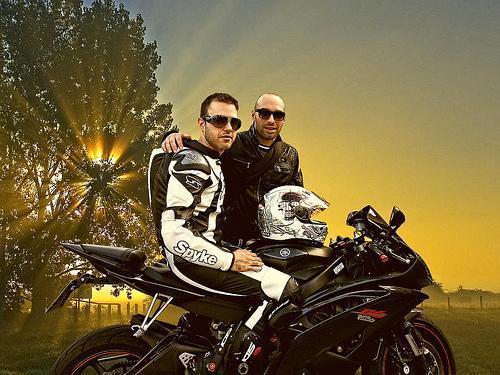How many people are there?
Give a very brief answer. 2. How many people have full head of hair in this picture?
Give a very brief answer. 1. 